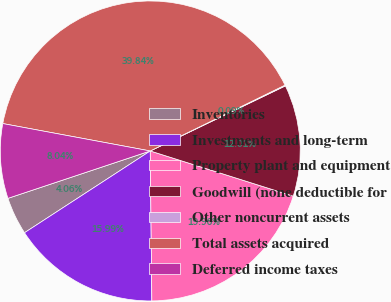Convert chart to OTSL. <chart><loc_0><loc_0><loc_500><loc_500><pie_chart><fcel>Inventories<fcel>Investments and long-term<fcel>Property plant and equipment<fcel>Goodwill (none deductible for<fcel>Other noncurrent assets<fcel>Total assets acquired<fcel>Deferred income taxes<nl><fcel>4.06%<fcel>15.99%<fcel>19.96%<fcel>12.01%<fcel>0.09%<fcel>39.84%<fcel>8.04%<nl></chart> 